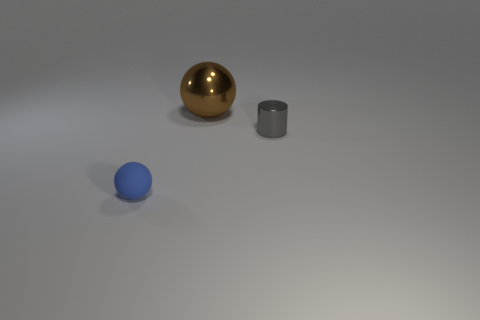Add 1 big metal things. How many objects exist? 4 Subtract all balls. How many objects are left? 1 Add 2 big cyan metal things. How many big cyan metal things exist? 2 Subtract 0 cyan blocks. How many objects are left? 3 Subtract all big cyan metal spheres. Subtract all metal objects. How many objects are left? 1 Add 1 tiny gray metallic cylinders. How many tiny gray metallic cylinders are left? 2 